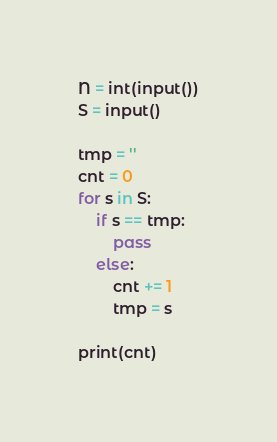<code> <loc_0><loc_0><loc_500><loc_500><_Python_>N = int(input())
S = input()

tmp = ''
cnt = 0
for s in S:
    if s == tmp:
        pass
    else:
        cnt += 1
        tmp = s
        
print(cnt)        </code> 